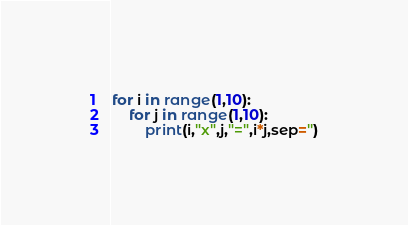Convert code to text. <code><loc_0><loc_0><loc_500><loc_500><_Python_>for i in range(1,10):
    for j in range(1,10):
        print(i,"x",j,"=",i*j,sep='')
</code> 